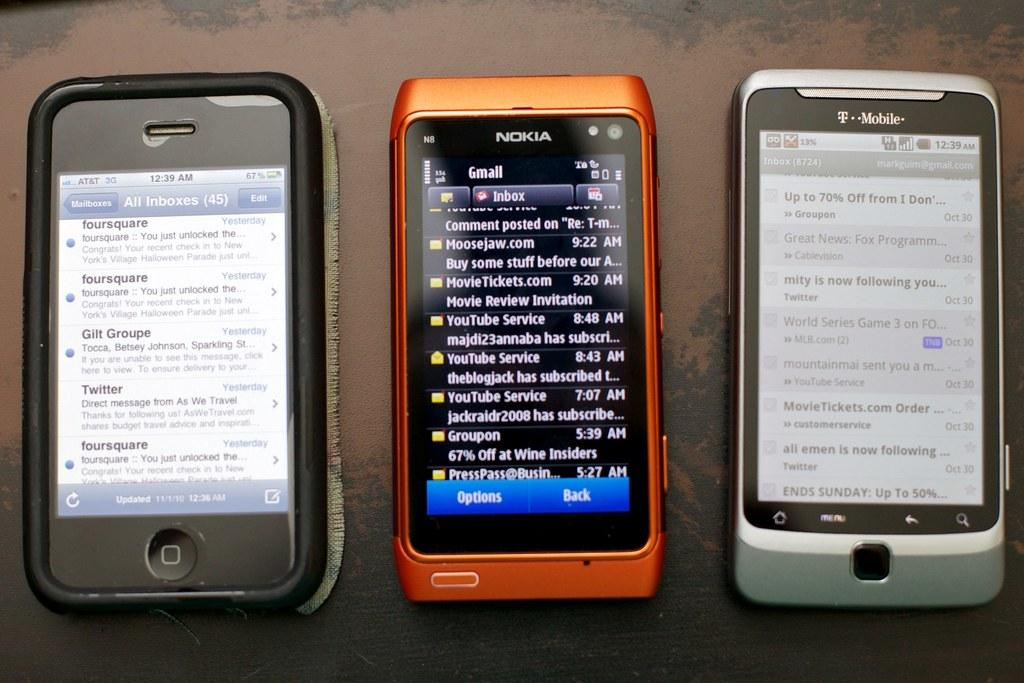<image>
Share a concise interpretation of the image provided. Orange phone between two other phones that say "Nokia" on it. 